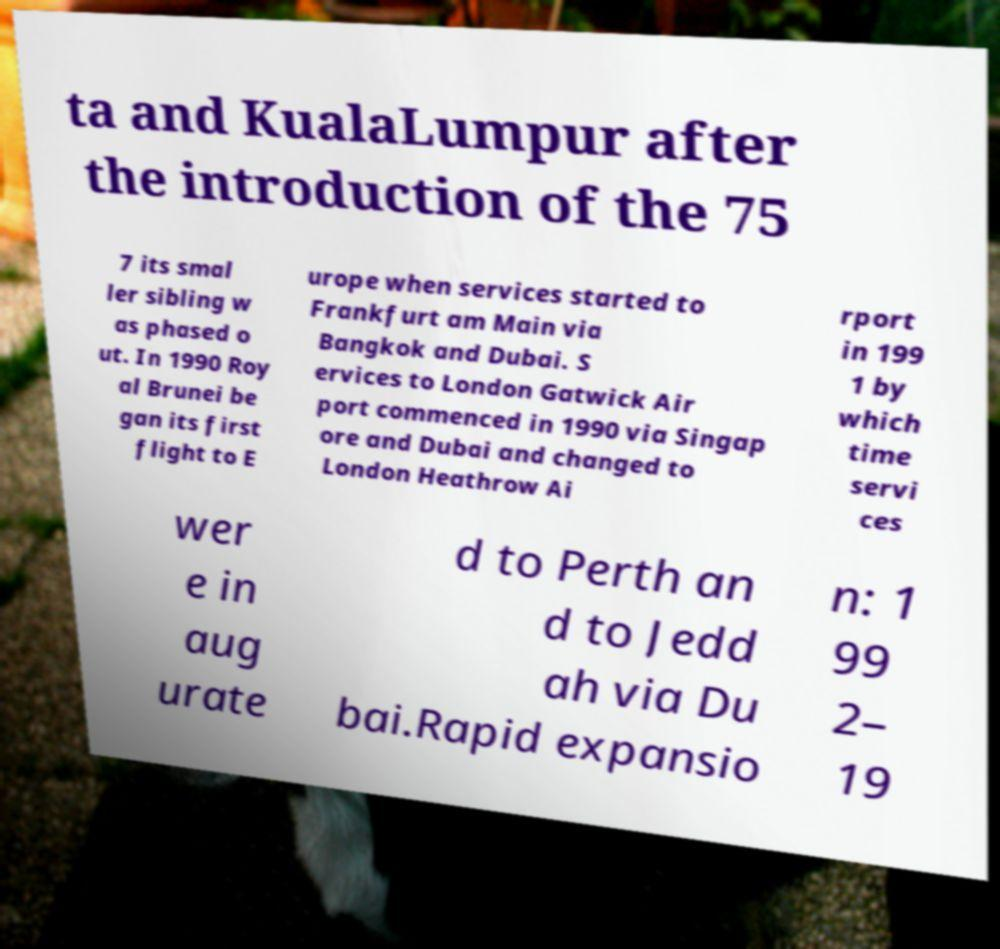Could you assist in decoding the text presented in this image and type it out clearly? ta and KualaLumpur after the introduction of the 75 7 its smal ler sibling w as phased o ut. In 1990 Roy al Brunei be gan its first flight to E urope when services started to Frankfurt am Main via Bangkok and Dubai. S ervices to London Gatwick Air port commenced in 1990 via Singap ore and Dubai and changed to London Heathrow Ai rport in 199 1 by which time servi ces wer e in aug urate d to Perth an d to Jedd ah via Du bai.Rapid expansio n: 1 99 2– 19 